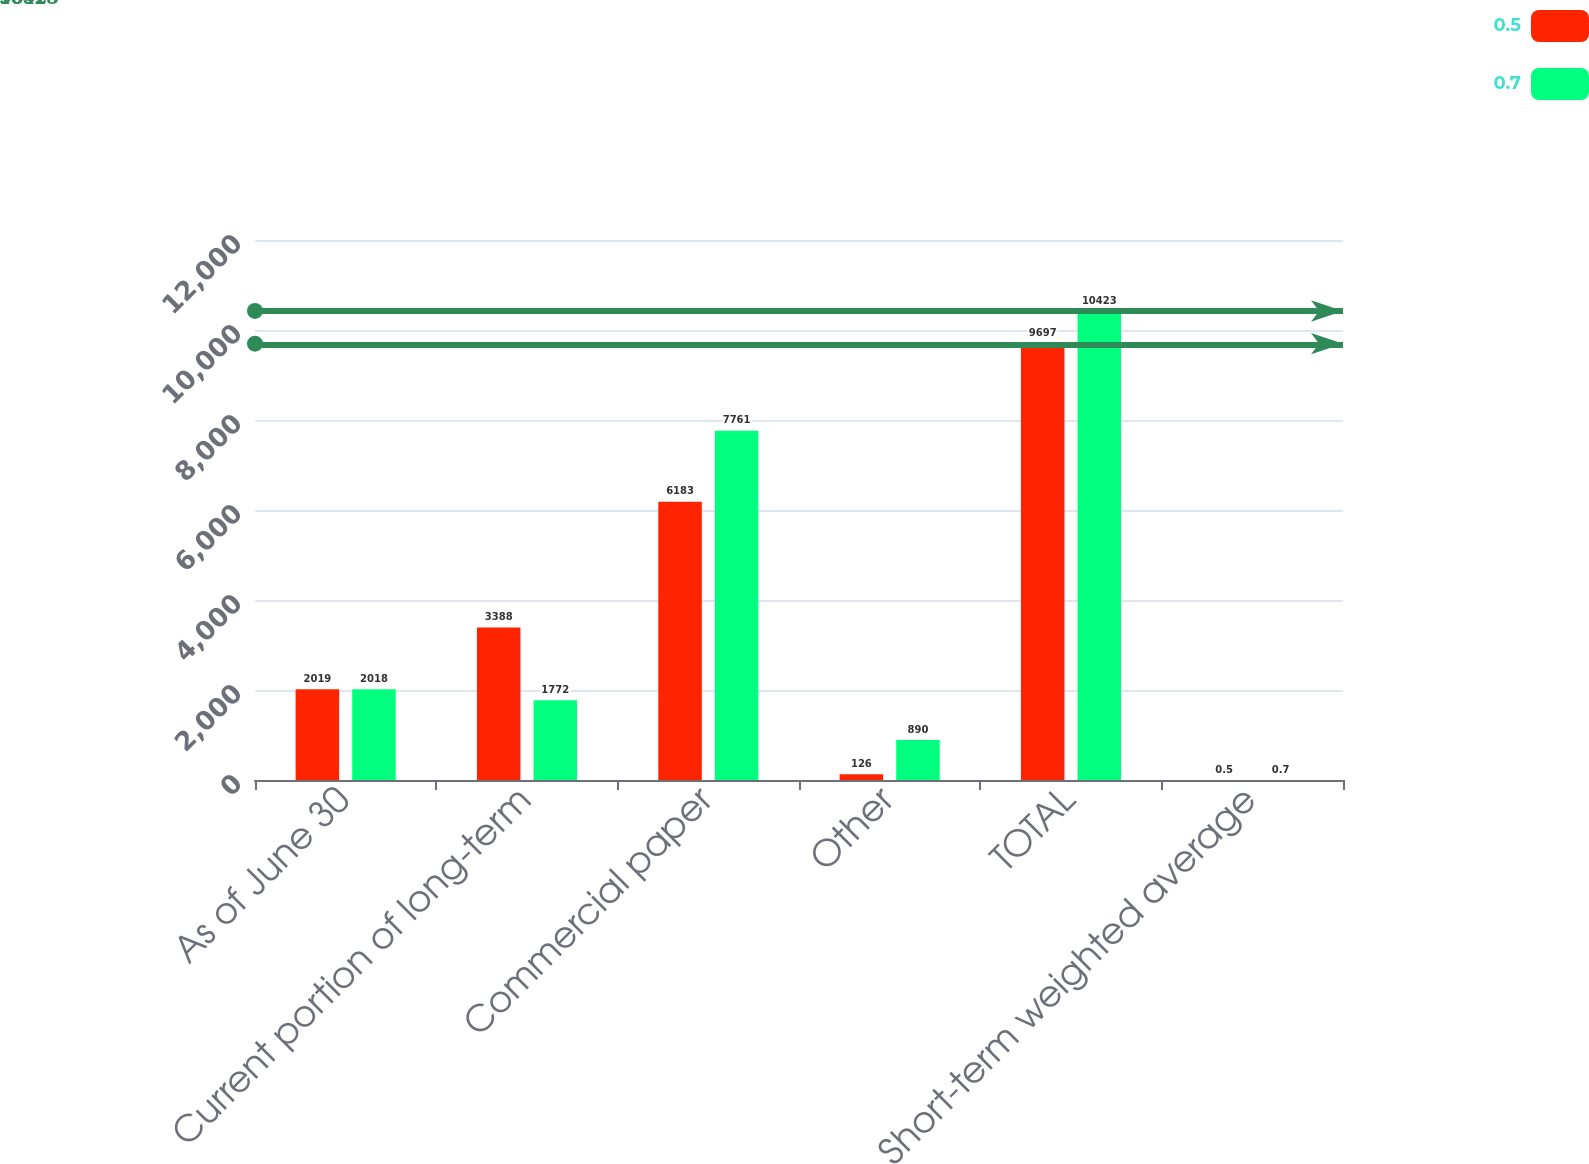<chart> <loc_0><loc_0><loc_500><loc_500><stacked_bar_chart><ecel><fcel>As of June 30<fcel>Current portion of long-term<fcel>Commercial paper<fcel>Other<fcel>TOTAL<fcel>Short-term weighted average<nl><fcel>0.5<fcel>2019<fcel>3388<fcel>6183<fcel>126<fcel>9697<fcel>0.5<nl><fcel>0.7<fcel>2018<fcel>1772<fcel>7761<fcel>890<fcel>10423<fcel>0.7<nl></chart> 